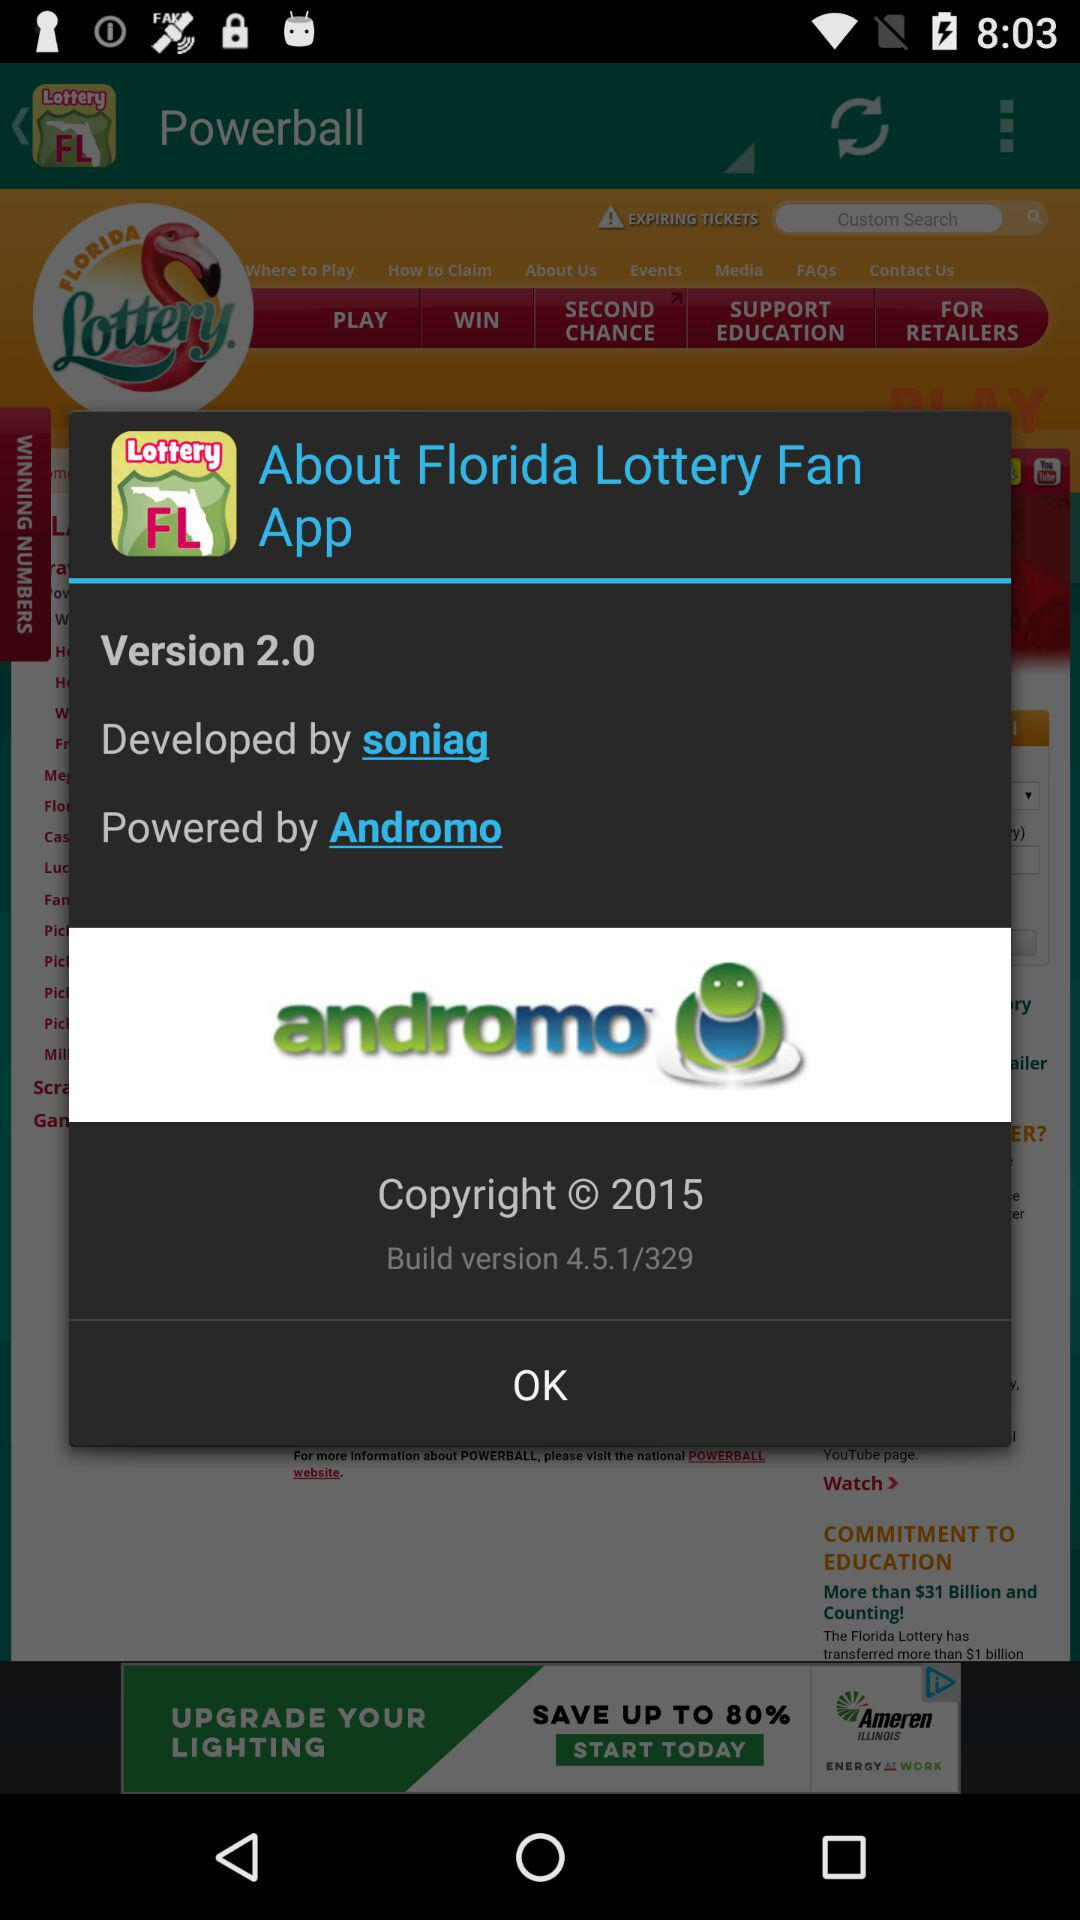Who is the developer of the application? The developer of the application is "soniag". 